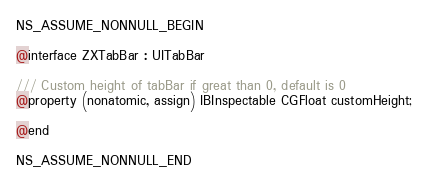<code> <loc_0><loc_0><loc_500><loc_500><_C_>NS_ASSUME_NONNULL_BEGIN

@interface ZXTabBar : UITabBar

/// Custom height of tabBar if great than 0, default is 0
@property (nonatomic, assign) IBInspectable CGFloat customHeight;

@end

NS_ASSUME_NONNULL_END
</code> 